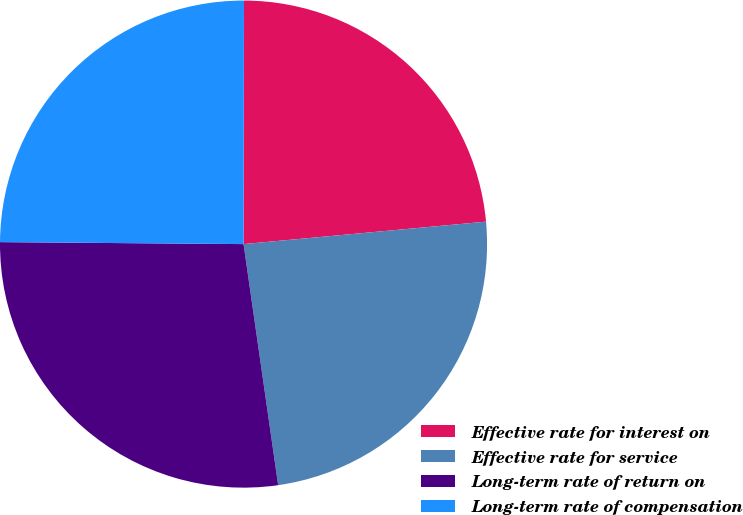Convert chart to OTSL. <chart><loc_0><loc_0><loc_500><loc_500><pie_chart><fcel>Effective rate for interest on<fcel>Effective rate for service<fcel>Long-term rate of return on<fcel>Long-term rate of compensation<nl><fcel>23.5%<fcel>24.2%<fcel>27.4%<fcel>24.9%<nl></chart> 